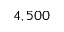<formula> <loc_0><loc_0><loc_500><loc_500>4 , 5 0 0</formula> 